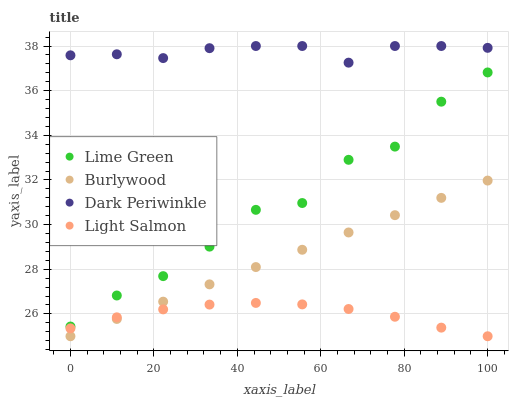Does Light Salmon have the minimum area under the curve?
Answer yes or no. Yes. Does Dark Periwinkle have the maximum area under the curve?
Answer yes or no. Yes. Does Lime Green have the minimum area under the curve?
Answer yes or no. No. Does Lime Green have the maximum area under the curve?
Answer yes or no. No. Is Burlywood the smoothest?
Answer yes or no. Yes. Is Lime Green the roughest?
Answer yes or no. Yes. Is Light Salmon the smoothest?
Answer yes or no. No. Is Light Salmon the roughest?
Answer yes or no. No. Does Burlywood have the lowest value?
Answer yes or no. Yes. Does Lime Green have the lowest value?
Answer yes or no. No. Does Dark Periwinkle have the highest value?
Answer yes or no. Yes. Does Lime Green have the highest value?
Answer yes or no. No. Is Light Salmon less than Lime Green?
Answer yes or no. Yes. Is Dark Periwinkle greater than Burlywood?
Answer yes or no. Yes. Does Burlywood intersect Light Salmon?
Answer yes or no. Yes. Is Burlywood less than Light Salmon?
Answer yes or no. No. Is Burlywood greater than Light Salmon?
Answer yes or no. No. Does Light Salmon intersect Lime Green?
Answer yes or no. No. 